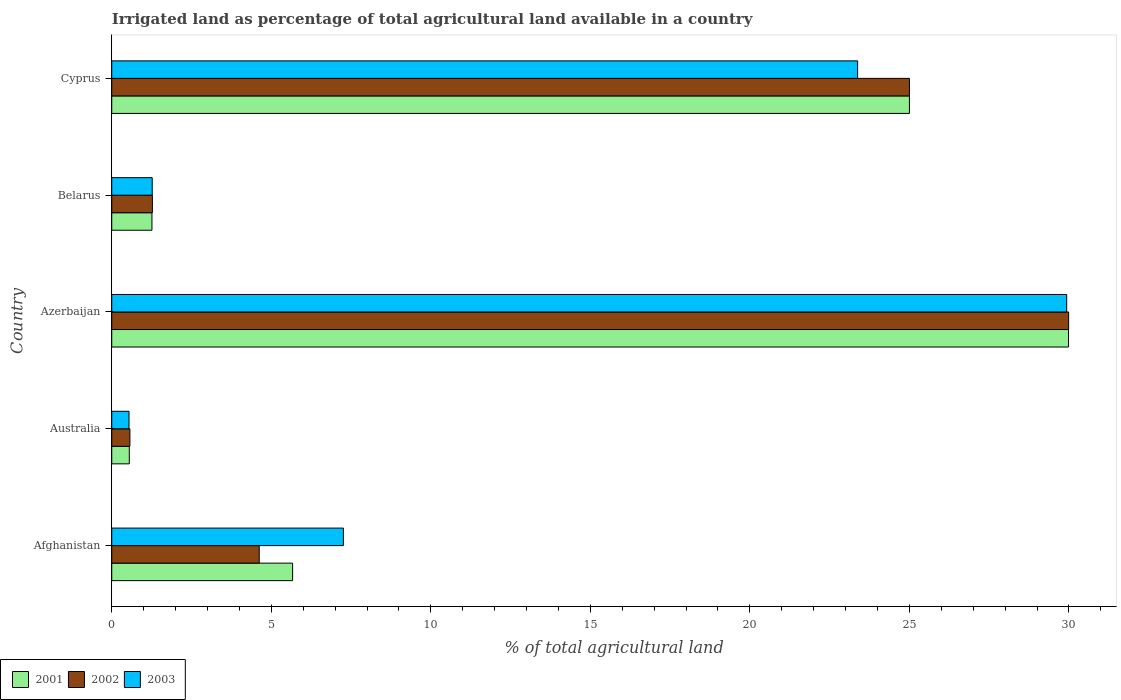How many groups of bars are there?
Ensure brevity in your answer.  5. Are the number of bars per tick equal to the number of legend labels?
Make the answer very short. Yes. Are the number of bars on each tick of the Y-axis equal?
Provide a succinct answer. Yes. How many bars are there on the 3rd tick from the top?
Your answer should be compact. 3. How many bars are there on the 3rd tick from the bottom?
Make the answer very short. 3. What is the label of the 5th group of bars from the top?
Your response must be concise. Afghanistan. In how many cases, is the number of bars for a given country not equal to the number of legend labels?
Give a very brief answer. 0. Across all countries, what is the maximum percentage of irrigated land in 2001?
Your answer should be very brief. 29.99. Across all countries, what is the minimum percentage of irrigated land in 2003?
Your answer should be compact. 0.54. In which country was the percentage of irrigated land in 2001 maximum?
Give a very brief answer. Azerbaijan. In which country was the percentage of irrigated land in 2001 minimum?
Ensure brevity in your answer.  Australia. What is the total percentage of irrigated land in 2003 in the graph?
Your answer should be very brief. 62.37. What is the difference between the percentage of irrigated land in 2003 in Azerbaijan and that in Belarus?
Your response must be concise. 28.66. What is the difference between the percentage of irrigated land in 2002 in Azerbaijan and the percentage of irrigated land in 2003 in Australia?
Offer a terse response. 29.45. What is the average percentage of irrigated land in 2001 per country?
Your response must be concise. 12.49. What is the difference between the percentage of irrigated land in 2001 and percentage of irrigated land in 2003 in Belarus?
Offer a terse response. -0.01. What is the ratio of the percentage of irrigated land in 2002 in Afghanistan to that in Azerbaijan?
Offer a terse response. 0.15. Is the percentage of irrigated land in 2001 in Australia less than that in Cyprus?
Provide a short and direct response. Yes. Is the difference between the percentage of irrigated land in 2001 in Afghanistan and Belarus greater than the difference between the percentage of irrigated land in 2003 in Afghanistan and Belarus?
Give a very brief answer. No. What is the difference between the highest and the second highest percentage of irrigated land in 2003?
Offer a terse response. 6.55. What is the difference between the highest and the lowest percentage of irrigated land in 2001?
Your answer should be compact. 29.44. In how many countries, is the percentage of irrigated land in 2001 greater than the average percentage of irrigated land in 2001 taken over all countries?
Ensure brevity in your answer.  2. How many bars are there?
Your response must be concise. 15. Are the values on the major ticks of X-axis written in scientific E-notation?
Offer a very short reply. No. Does the graph contain any zero values?
Give a very brief answer. No. Where does the legend appear in the graph?
Offer a very short reply. Bottom left. What is the title of the graph?
Your response must be concise. Irrigated land as percentage of total agricultural land available in a country. What is the label or title of the X-axis?
Offer a terse response. % of total agricultural land. What is the % of total agricultural land in 2001 in Afghanistan?
Keep it short and to the point. 5.67. What is the % of total agricultural land of 2002 in Afghanistan?
Offer a very short reply. 4.62. What is the % of total agricultural land of 2003 in Afghanistan?
Make the answer very short. 7.26. What is the % of total agricultural land in 2001 in Australia?
Offer a very short reply. 0.55. What is the % of total agricultural land of 2002 in Australia?
Give a very brief answer. 0.57. What is the % of total agricultural land in 2003 in Australia?
Provide a succinct answer. 0.54. What is the % of total agricultural land of 2001 in Azerbaijan?
Provide a short and direct response. 29.99. What is the % of total agricultural land in 2002 in Azerbaijan?
Ensure brevity in your answer.  29.99. What is the % of total agricultural land in 2003 in Azerbaijan?
Your answer should be compact. 29.93. What is the % of total agricultural land of 2001 in Belarus?
Offer a very short reply. 1.26. What is the % of total agricultural land in 2002 in Belarus?
Your answer should be compact. 1.27. What is the % of total agricultural land in 2003 in Belarus?
Provide a succinct answer. 1.27. What is the % of total agricultural land in 2002 in Cyprus?
Make the answer very short. 25. What is the % of total agricultural land in 2003 in Cyprus?
Make the answer very short. 23.38. Across all countries, what is the maximum % of total agricultural land in 2001?
Provide a succinct answer. 29.99. Across all countries, what is the maximum % of total agricultural land in 2002?
Your answer should be very brief. 29.99. Across all countries, what is the maximum % of total agricultural land in 2003?
Offer a terse response. 29.93. Across all countries, what is the minimum % of total agricultural land in 2001?
Your answer should be very brief. 0.55. Across all countries, what is the minimum % of total agricultural land of 2002?
Your response must be concise. 0.57. Across all countries, what is the minimum % of total agricultural land of 2003?
Give a very brief answer. 0.54. What is the total % of total agricultural land in 2001 in the graph?
Make the answer very short. 62.46. What is the total % of total agricultural land in 2002 in the graph?
Give a very brief answer. 61.46. What is the total % of total agricultural land of 2003 in the graph?
Keep it short and to the point. 62.37. What is the difference between the % of total agricultural land in 2001 in Afghanistan and that in Australia?
Keep it short and to the point. 5.12. What is the difference between the % of total agricultural land of 2002 in Afghanistan and that in Australia?
Make the answer very short. 4.05. What is the difference between the % of total agricultural land in 2003 in Afghanistan and that in Australia?
Your answer should be very brief. 6.72. What is the difference between the % of total agricultural land in 2001 in Afghanistan and that in Azerbaijan?
Offer a terse response. -24.32. What is the difference between the % of total agricultural land in 2002 in Afghanistan and that in Azerbaijan?
Give a very brief answer. -25.37. What is the difference between the % of total agricultural land of 2003 in Afghanistan and that in Azerbaijan?
Offer a terse response. -22.67. What is the difference between the % of total agricultural land of 2001 in Afghanistan and that in Belarus?
Provide a succinct answer. 4.41. What is the difference between the % of total agricultural land in 2002 in Afghanistan and that in Belarus?
Offer a terse response. 3.35. What is the difference between the % of total agricultural land in 2003 in Afghanistan and that in Belarus?
Keep it short and to the point. 5.99. What is the difference between the % of total agricultural land of 2001 in Afghanistan and that in Cyprus?
Your answer should be compact. -19.33. What is the difference between the % of total agricultural land in 2002 in Afghanistan and that in Cyprus?
Make the answer very short. -20.38. What is the difference between the % of total agricultural land in 2003 in Afghanistan and that in Cyprus?
Offer a very short reply. -16.12. What is the difference between the % of total agricultural land in 2001 in Australia and that in Azerbaijan?
Offer a terse response. -29.44. What is the difference between the % of total agricultural land in 2002 in Australia and that in Azerbaijan?
Your response must be concise. -29.42. What is the difference between the % of total agricultural land in 2003 in Australia and that in Azerbaijan?
Make the answer very short. -29.39. What is the difference between the % of total agricultural land of 2001 in Australia and that in Belarus?
Give a very brief answer. -0.71. What is the difference between the % of total agricultural land of 2002 in Australia and that in Belarus?
Provide a succinct answer. -0.7. What is the difference between the % of total agricultural land in 2003 in Australia and that in Belarus?
Your answer should be compact. -0.73. What is the difference between the % of total agricultural land of 2001 in Australia and that in Cyprus?
Your answer should be compact. -24.45. What is the difference between the % of total agricultural land in 2002 in Australia and that in Cyprus?
Provide a succinct answer. -24.43. What is the difference between the % of total agricultural land in 2003 in Australia and that in Cyprus?
Make the answer very short. -22.84. What is the difference between the % of total agricultural land of 2001 in Azerbaijan and that in Belarus?
Offer a terse response. 28.73. What is the difference between the % of total agricultural land in 2002 in Azerbaijan and that in Belarus?
Offer a very short reply. 28.72. What is the difference between the % of total agricultural land of 2003 in Azerbaijan and that in Belarus?
Make the answer very short. 28.66. What is the difference between the % of total agricultural land in 2001 in Azerbaijan and that in Cyprus?
Offer a very short reply. 4.99. What is the difference between the % of total agricultural land in 2002 in Azerbaijan and that in Cyprus?
Give a very brief answer. 4.99. What is the difference between the % of total agricultural land of 2003 in Azerbaijan and that in Cyprus?
Provide a succinct answer. 6.55. What is the difference between the % of total agricultural land of 2001 in Belarus and that in Cyprus?
Offer a terse response. -23.74. What is the difference between the % of total agricultural land of 2002 in Belarus and that in Cyprus?
Provide a short and direct response. -23.73. What is the difference between the % of total agricultural land in 2003 in Belarus and that in Cyprus?
Provide a succinct answer. -22.11. What is the difference between the % of total agricultural land in 2001 in Afghanistan and the % of total agricultural land in 2002 in Australia?
Offer a very short reply. 5.1. What is the difference between the % of total agricultural land of 2001 in Afghanistan and the % of total agricultural land of 2003 in Australia?
Your answer should be very brief. 5.13. What is the difference between the % of total agricultural land in 2002 in Afghanistan and the % of total agricultural land in 2003 in Australia?
Keep it short and to the point. 4.08. What is the difference between the % of total agricultural land in 2001 in Afghanistan and the % of total agricultural land in 2002 in Azerbaijan?
Ensure brevity in your answer.  -24.32. What is the difference between the % of total agricultural land of 2001 in Afghanistan and the % of total agricultural land of 2003 in Azerbaijan?
Offer a terse response. -24.26. What is the difference between the % of total agricultural land of 2002 in Afghanistan and the % of total agricultural land of 2003 in Azerbaijan?
Keep it short and to the point. -25.31. What is the difference between the % of total agricultural land in 2001 in Afghanistan and the % of total agricultural land in 2002 in Belarus?
Your answer should be compact. 4.39. What is the difference between the % of total agricultural land of 2001 in Afghanistan and the % of total agricultural land of 2003 in Belarus?
Offer a terse response. 4.4. What is the difference between the % of total agricultural land of 2002 in Afghanistan and the % of total agricultural land of 2003 in Belarus?
Keep it short and to the point. 3.35. What is the difference between the % of total agricultural land in 2001 in Afghanistan and the % of total agricultural land in 2002 in Cyprus?
Make the answer very short. -19.33. What is the difference between the % of total agricultural land in 2001 in Afghanistan and the % of total agricultural land in 2003 in Cyprus?
Provide a succinct answer. -17.71. What is the difference between the % of total agricultural land of 2002 in Afghanistan and the % of total agricultural land of 2003 in Cyprus?
Provide a short and direct response. -18.75. What is the difference between the % of total agricultural land of 2001 in Australia and the % of total agricultural land of 2002 in Azerbaijan?
Provide a short and direct response. -29.44. What is the difference between the % of total agricultural land of 2001 in Australia and the % of total agricultural land of 2003 in Azerbaijan?
Make the answer very short. -29.38. What is the difference between the % of total agricultural land of 2002 in Australia and the % of total agricultural land of 2003 in Azerbaijan?
Give a very brief answer. -29.36. What is the difference between the % of total agricultural land of 2001 in Australia and the % of total agricultural land of 2002 in Belarus?
Your response must be concise. -0.72. What is the difference between the % of total agricultural land in 2001 in Australia and the % of total agricultural land in 2003 in Belarus?
Your response must be concise. -0.72. What is the difference between the % of total agricultural land of 2002 in Australia and the % of total agricultural land of 2003 in Belarus?
Make the answer very short. -0.7. What is the difference between the % of total agricultural land in 2001 in Australia and the % of total agricultural land in 2002 in Cyprus?
Provide a succinct answer. -24.45. What is the difference between the % of total agricultural land of 2001 in Australia and the % of total agricultural land of 2003 in Cyprus?
Offer a terse response. -22.83. What is the difference between the % of total agricultural land in 2002 in Australia and the % of total agricultural land in 2003 in Cyprus?
Provide a short and direct response. -22.81. What is the difference between the % of total agricultural land of 2001 in Azerbaijan and the % of total agricultural land of 2002 in Belarus?
Offer a terse response. 28.71. What is the difference between the % of total agricultural land of 2001 in Azerbaijan and the % of total agricultural land of 2003 in Belarus?
Your answer should be very brief. 28.72. What is the difference between the % of total agricultural land of 2002 in Azerbaijan and the % of total agricultural land of 2003 in Belarus?
Keep it short and to the point. 28.72. What is the difference between the % of total agricultural land in 2001 in Azerbaijan and the % of total agricultural land in 2002 in Cyprus?
Your answer should be very brief. 4.99. What is the difference between the % of total agricultural land of 2001 in Azerbaijan and the % of total agricultural land of 2003 in Cyprus?
Keep it short and to the point. 6.61. What is the difference between the % of total agricultural land of 2002 in Azerbaijan and the % of total agricultural land of 2003 in Cyprus?
Ensure brevity in your answer.  6.61. What is the difference between the % of total agricultural land of 2001 in Belarus and the % of total agricultural land of 2002 in Cyprus?
Offer a terse response. -23.74. What is the difference between the % of total agricultural land of 2001 in Belarus and the % of total agricultural land of 2003 in Cyprus?
Provide a succinct answer. -22.12. What is the difference between the % of total agricultural land of 2002 in Belarus and the % of total agricultural land of 2003 in Cyprus?
Your response must be concise. -22.1. What is the average % of total agricultural land in 2001 per country?
Your answer should be very brief. 12.49. What is the average % of total agricultural land in 2002 per country?
Give a very brief answer. 12.29. What is the average % of total agricultural land of 2003 per country?
Ensure brevity in your answer.  12.47. What is the difference between the % of total agricultural land of 2001 and % of total agricultural land of 2002 in Afghanistan?
Keep it short and to the point. 1.05. What is the difference between the % of total agricultural land of 2001 and % of total agricultural land of 2003 in Afghanistan?
Offer a terse response. -1.59. What is the difference between the % of total agricultural land in 2002 and % of total agricultural land in 2003 in Afghanistan?
Give a very brief answer. -2.64. What is the difference between the % of total agricultural land of 2001 and % of total agricultural land of 2002 in Australia?
Your answer should be compact. -0.02. What is the difference between the % of total agricultural land in 2001 and % of total agricultural land in 2003 in Australia?
Offer a very short reply. 0.01. What is the difference between the % of total agricultural land of 2002 and % of total agricultural land of 2003 in Australia?
Offer a very short reply. 0.03. What is the difference between the % of total agricultural land of 2001 and % of total agricultural land of 2002 in Azerbaijan?
Your response must be concise. -0. What is the difference between the % of total agricultural land of 2001 and % of total agricultural land of 2003 in Azerbaijan?
Provide a short and direct response. 0.06. What is the difference between the % of total agricultural land in 2002 and % of total agricultural land in 2003 in Azerbaijan?
Provide a short and direct response. 0.06. What is the difference between the % of total agricultural land in 2001 and % of total agricultural land in 2002 in Belarus?
Offer a very short reply. -0.01. What is the difference between the % of total agricultural land of 2001 and % of total agricultural land of 2003 in Belarus?
Give a very brief answer. -0.01. What is the difference between the % of total agricultural land of 2002 and % of total agricultural land of 2003 in Belarus?
Keep it short and to the point. 0.01. What is the difference between the % of total agricultural land in 2001 and % of total agricultural land in 2003 in Cyprus?
Offer a terse response. 1.62. What is the difference between the % of total agricultural land of 2002 and % of total agricultural land of 2003 in Cyprus?
Provide a short and direct response. 1.62. What is the ratio of the % of total agricultural land of 2001 in Afghanistan to that in Australia?
Your response must be concise. 10.31. What is the ratio of the % of total agricultural land in 2002 in Afghanistan to that in Australia?
Provide a succinct answer. 8.12. What is the ratio of the % of total agricultural land in 2003 in Afghanistan to that in Australia?
Make the answer very short. 13.42. What is the ratio of the % of total agricultural land in 2001 in Afghanistan to that in Azerbaijan?
Your answer should be very brief. 0.19. What is the ratio of the % of total agricultural land in 2002 in Afghanistan to that in Azerbaijan?
Offer a very short reply. 0.15. What is the ratio of the % of total agricultural land of 2003 in Afghanistan to that in Azerbaijan?
Your response must be concise. 0.24. What is the ratio of the % of total agricultural land of 2001 in Afghanistan to that in Belarus?
Your answer should be very brief. 4.5. What is the ratio of the % of total agricultural land of 2002 in Afghanistan to that in Belarus?
Give a very brief answer. 3.63. What is the ratio of the % of total agricultural land in 2003 in Afghanistan to that in Belarus?
Make the answer very short. 5.72. What is the ratio of the % of total agricultural land in 2001 in Afghanistan to that in Cyprus?
Your response must be concise. 0.23. What is the ratio of the % of total agricultural land of 2002 in Afghanistan to that in Cyprus?
Ensure brevity in your answer.  0.18. What is the ratio of the % of total agricultural land in 2003 in Afghanistan to that in Cyprus?
Make the answer very short. 0.31. What is the ratio of the % of total agricultural land in 2001 in Australia to that in Azerbaijan?
Keep it short and to the point. 0.02. What is the ratio of the % of total agricultural land of 2002 in Australia to that in Azerbaijan?
Ensure brevity in your answer.  0.02. What is the ratio of the % of total agricultural land in 2003 in Australia to that in Azerbaijan?
Your answer should be compact. 0.02. What is the ratio of the % of total agricultural land of 2001 in Australia to that in Belarus?
Keep it short and to the point. 0.44. What is the ratio of the % of total agricultural land in 2002 in Australia to that in Belarus?
Provide a short and direct response. 0.45. What is the ratio of the % of total agricultural land of 2003 in Australia to that in Belarus?
Your response must be concise. 0.43. What is the ratio of the % of total agricultural land in 2001 in Australia to that in Cyprus?
Offer a terse response. 0.02. What is the ratio of the % of total agricultural land in 2002 in Australia to that in Cyprus?
Your response must be concise. 0.02. What is the ratio of the % of total agricultural land in 2003 in Australia to that in Cyprus?
Your answer should be very brief. 0.02. What is the ratio of the % of total agricultural land of 2001 in Azerbaijan to that in Belarus?
Your response must be concise. 23.8. What is the ratio of the % of total agricultural land of 2002 in Azerbaijan to that in Belarus?
Offer a very short reply. 23.54. What is the ratio of the % of total agricultural land in 2003 in Azerbaijan to that in Belarus?
Give a very brief answer. 23.59. What is the ratio of the % of total agricultural land in 2001 in Azerbaijan to that in Cyprus?
Provide a succinct answer. 1.2. What is the ratio of the % of total agricultural land in 2002 in Azerbaijan to that in Cyprus?
Give a very brief answer. 1.2. What is the ratio of the % of total agricultural land of 2003 in Azerbaijan to that in Cyprus?
Ensure brevity in your answer.  1.28. What is the ratio of the % of total agricultural land of 2001 in Belarus to that in Cyprus?
Keep it short and to the point. 0.05. What is the ratio of the % of total agricultural land in 2002 in Belarus to that in Cyprus?
Offer a very short reply. 0.05. What is the ratio of the % of total agricultural land of 2003 in Belarus to that in Cyprus?
Give a very brief answer. 0.05. What is the difference between the highest and the second highest % of total agricultural land of 2001?
Provide a succinct answer. 4.99. What is the difference between the highest and the second highest % of total agricultural land of 2002?
Offer a very short reply. 4.99. What is the difference between the highest and the second highest % of total agricultural land of 2003?
Offer a very short reply. 6.55. What is the difference between the highest and the lowest % of total agricultural land in 2001?
Offer a terse response. 29.44. What is the difference between the highest and the lowest % of total agricultural land of 2002?
Your response must be concise. 29.42. What is the difference between the highest and the lowest % of total agricultural land of 2003?
Give a very brief answer. 29.39. 